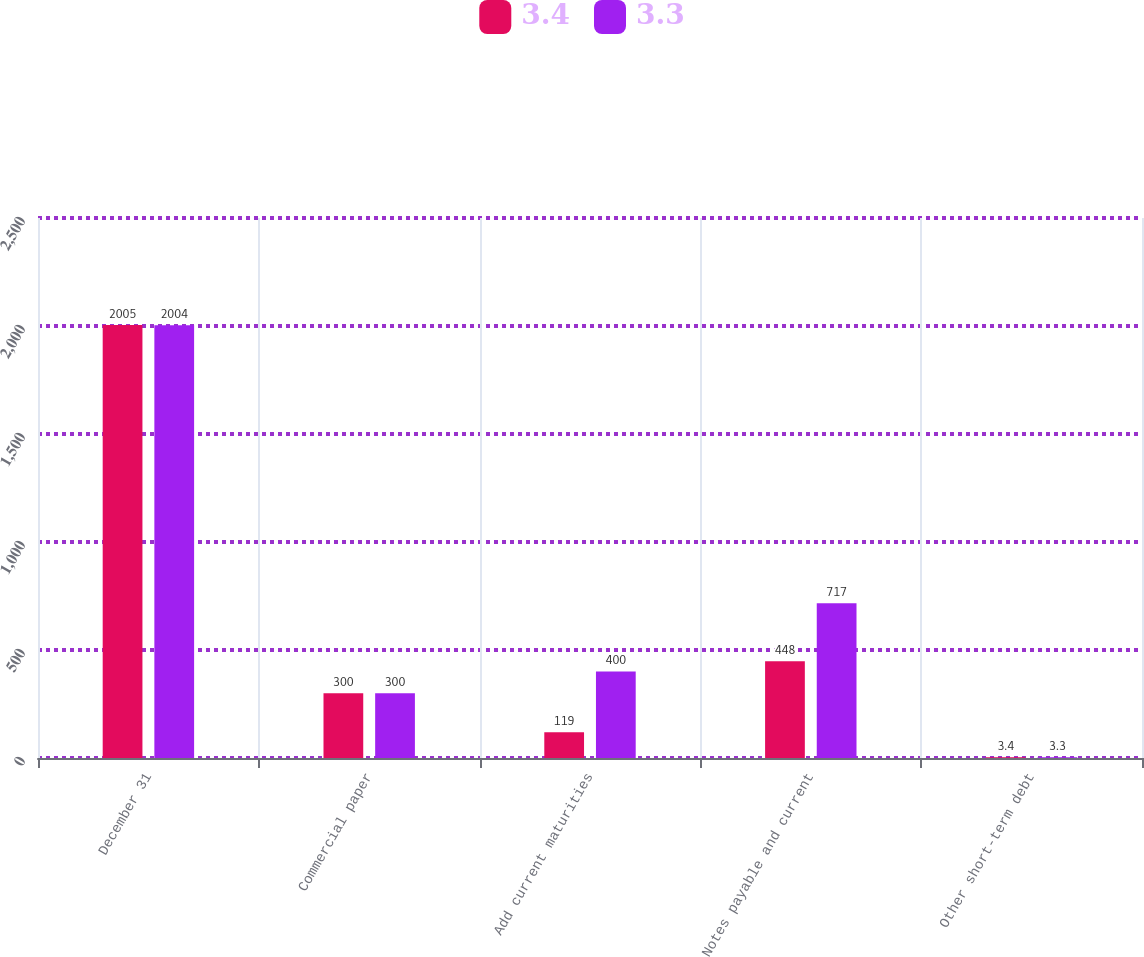Convert chart to OTSL. <chart><loc_0><loc_0><loc_500><loc_500><stacked_bar_chart><ecel><fcel>December 31<fcel>Commercial paper<fcel>Add current maturities<fcel>Notes payable and current<fcel>Other short-term debt<nl><fcel>3.4<fcel>2005<fcel>300<fcel>119<fcel>448<fcel>3.4<nl><fcel>3.3<fcel>2004<fcel>300<fcel>400<fcel>717<fcel>3.3<nl></chart> 